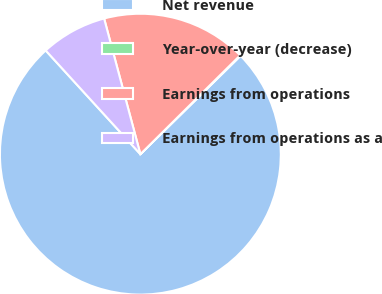Convert chart to OTSL. <chart><loc_0><loc_0><loc_500><loc_500><pie_chart><fcel>Net revenue<fcel>Year-over-year (decrease)<fcel>Earnings from operations<fcel>Earnings from operations as a<nl><fcel>75.58%<fcel>0.07%<fcel>16.73%<fcel>7.62%<nl></chart> 